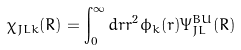<formula> <loc_0><loc_0><loc_500><loc_500>\chi _ { J L k } ( R ) = \int _ { 0 } ^ { \infty } d r r ^ { 2 } \phi _ { k } ( r ) \Psi _ { J L } ^ { B U } ( R )</formula> 